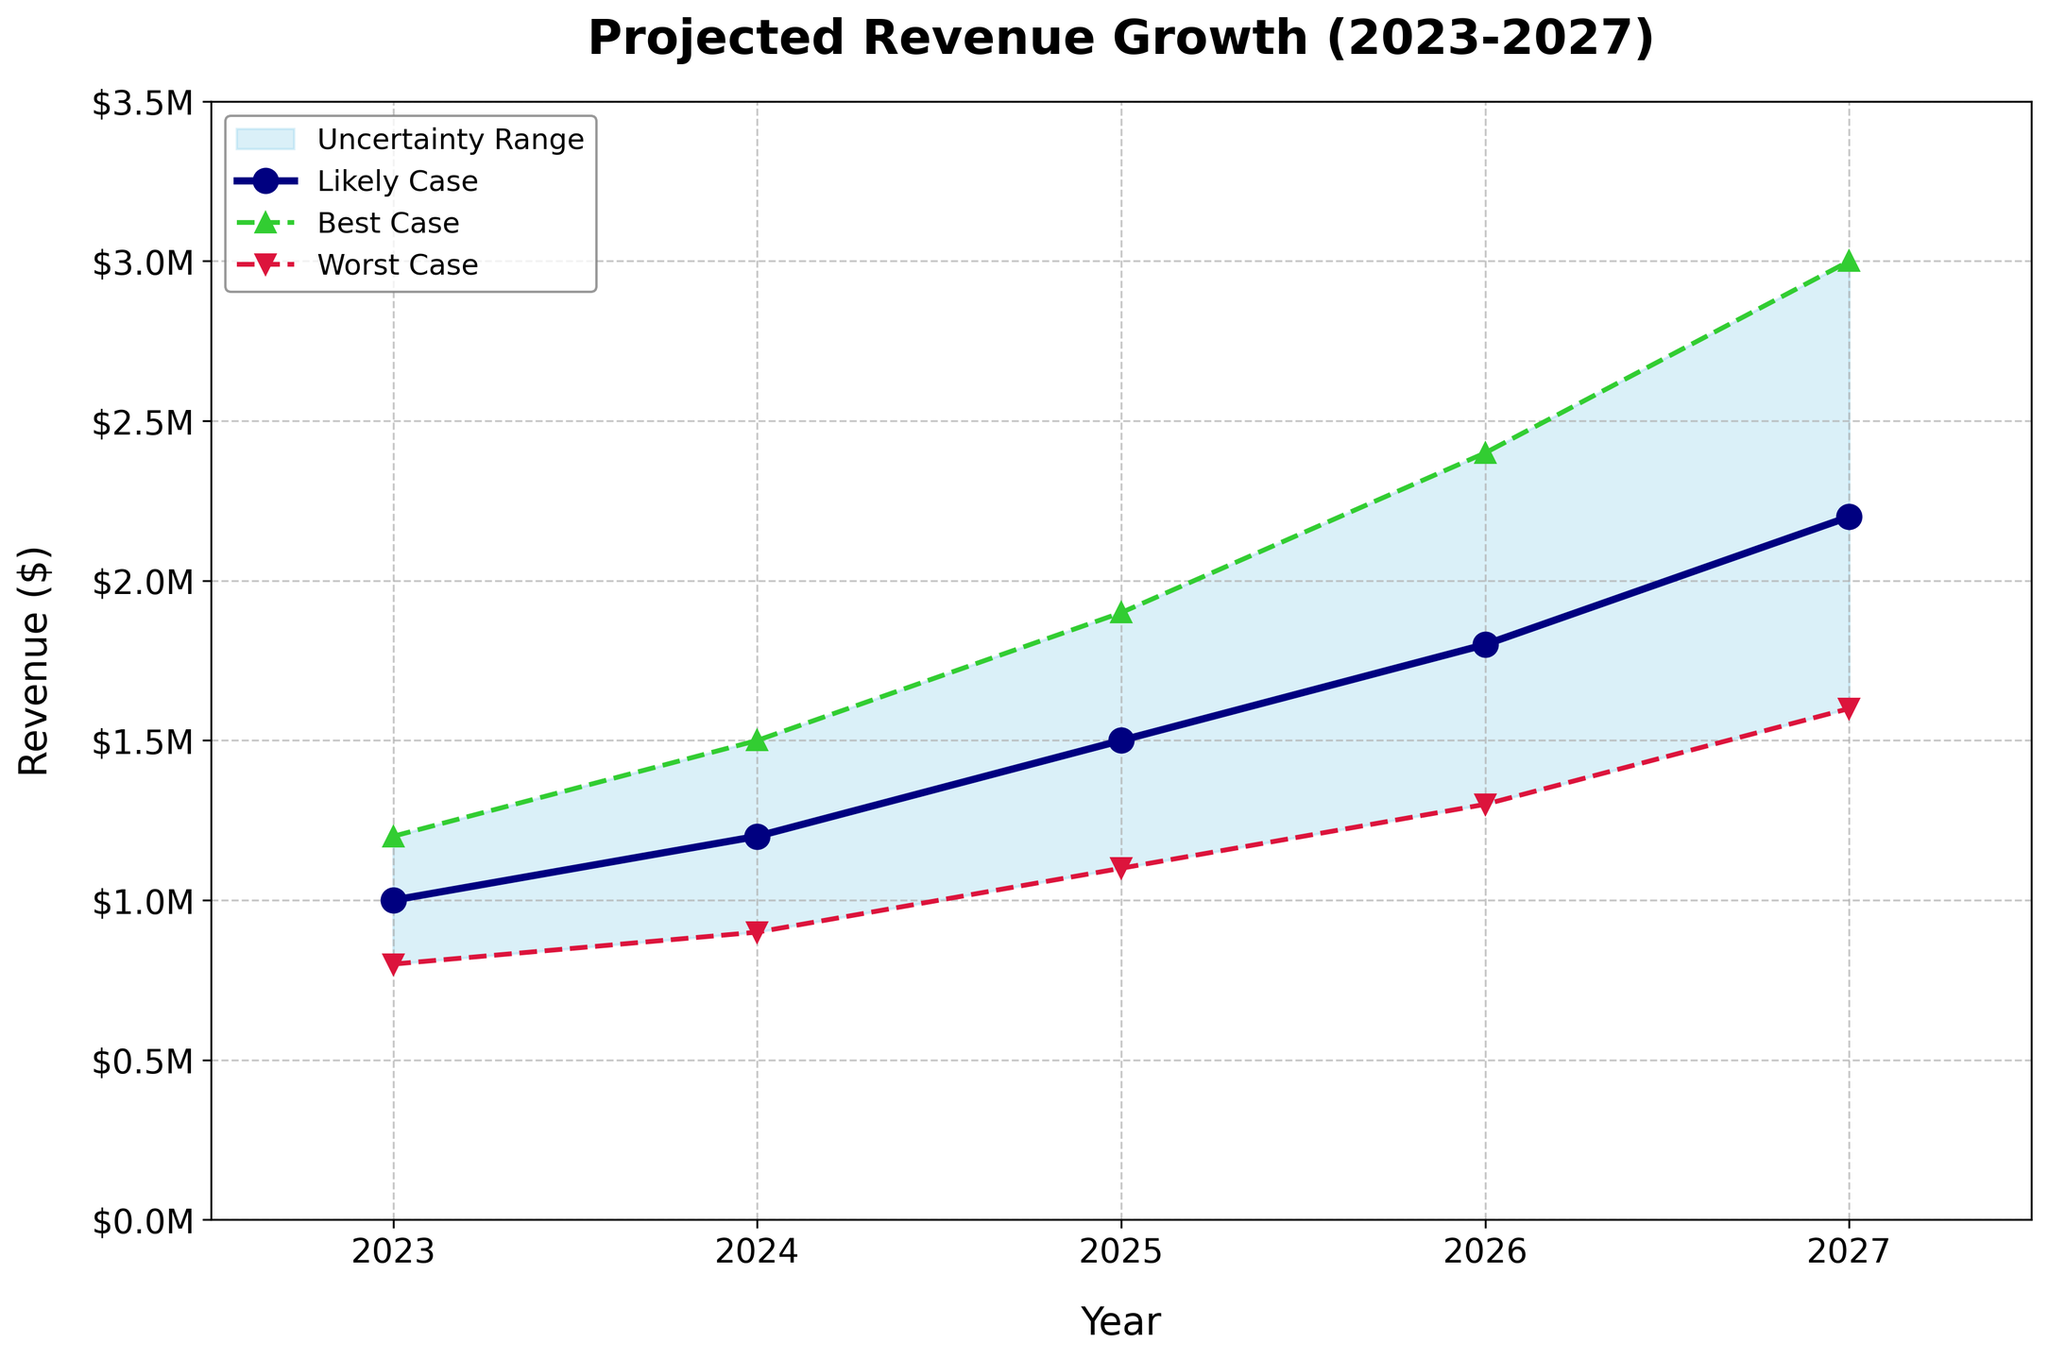What is the title of the plot? The title is often located at the top of the plot, and in this case, it clearly states "Projected Revenue Growth (2023-2027)".
Answer: Projected Revenue Growth (2023-2027) What color represents the likely case revenue in the plot? The likely case revenue is represented by a dark navy line that is prominent in the plot.
Answer: Navy How many years does the plot cover? The x-axis starts at 2023 and ends at 2027, so we can count the years included in this range as 5.
Answer: 5 In which year does the worst-case scenario reach $1,600,000? Observing the worst-case scenario line marked with red triangles, it reaches $1,600,000 in the year 2027.
Answer: 2027 What is the projected best-case revenue for the year 2025? By looking at the highest green dashed line, for the year 2025, the best-case revenue is marked exactly at $1,900,000.
Answer: $1,900,000 How does the uncertainty range change between 2023 and 2027? From 2023 to 2027, the uncertainty range expands as the difference between the best-case and worst-case revenue grows. This can be seen as the shaded light blue area becomes wider over time.
Answer: It increases What is the percentage difference between the likely case and worst-case revenue for the year 2024? Subtract the worst-case from the likely case for 2024 to get $300,000. Then divide by the worst-case revenue ($900,000) and multiply by 100 to get the percentage: ($300,000 / $900,000) * 100.
Answer: 33.3% In which year is the growth in likely case revenue the highest compared to the previous year? Calculate the differences year over year: 2024-2023 ($200,000), 2025-2024 ($300,000), 2026-2025 ($300,000), 2027-2026 ($400,000). The largest is from 2026 to 2027, which is $400,000.
Answer: 2027 What is the range of projected revenue in 2026? The best-case scenario for 2026 is $2,400,000 and the worst-case scenario is $1,300,000. The range is the difference: $2,400,000 - $1,300,000.
Answer: $1,100,000 By what factor does the best-case revenue projection for 2027 increase from the likely case for 2023? Divide the best-case revenue for 2027 ($3,000,000) by the likely case for 2023 ($1,000,000): $3,000,000 / $1,000,000.
Answer: 3 